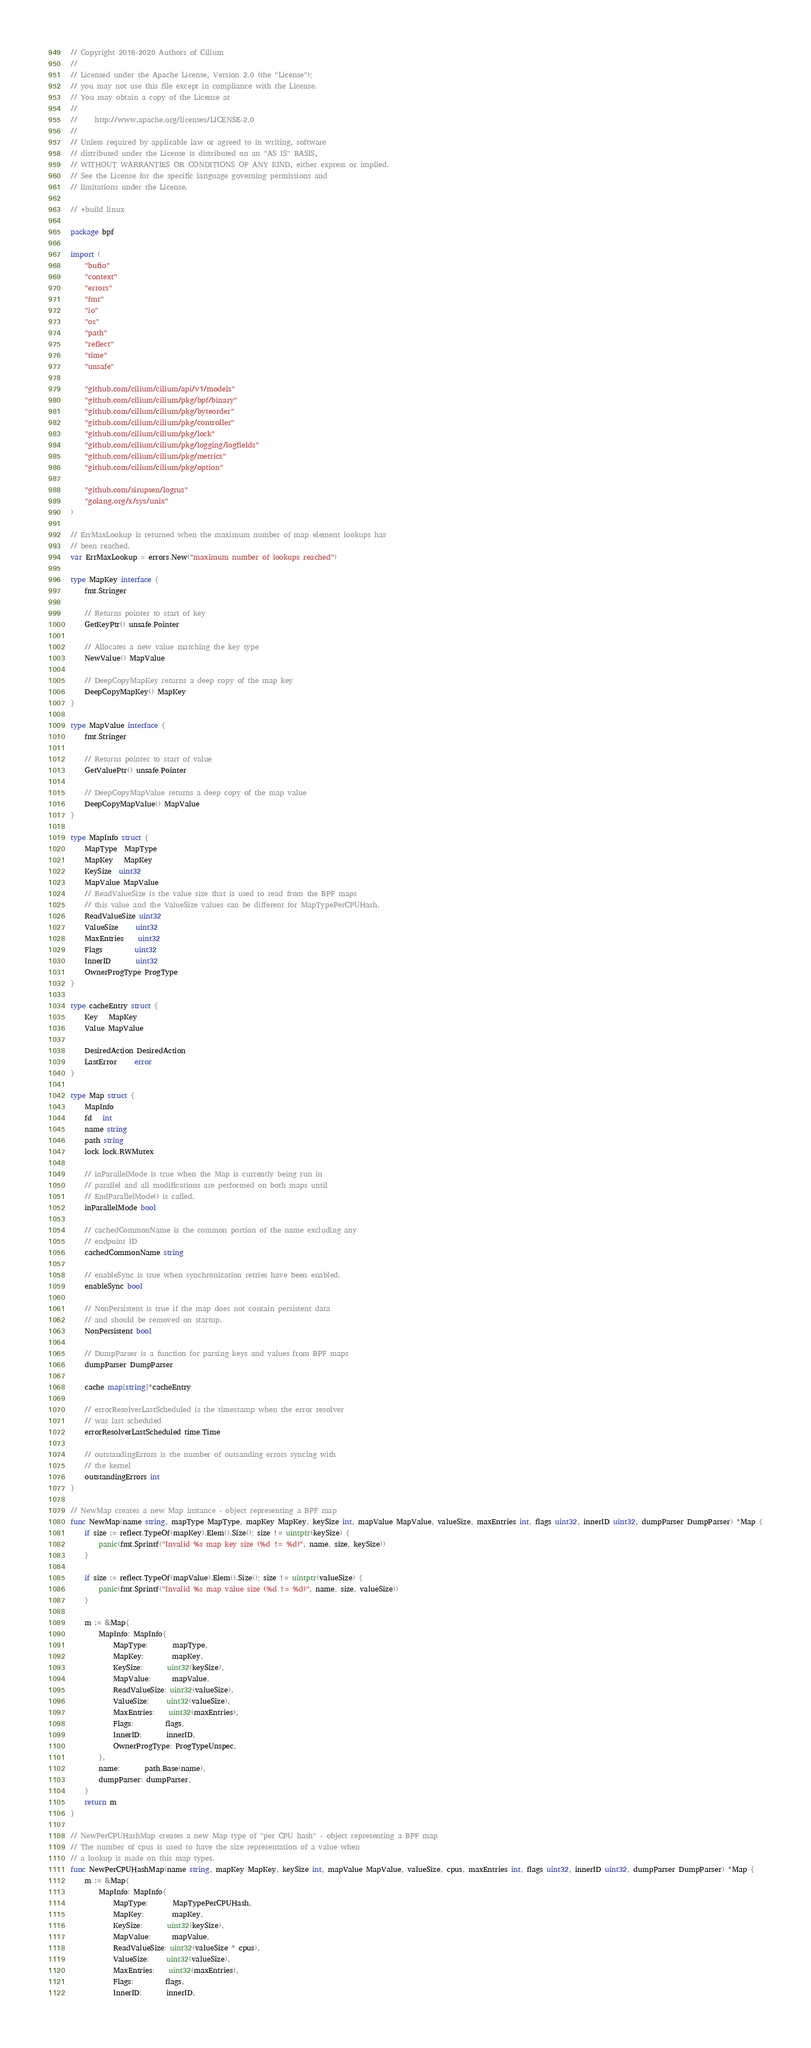<code> <loc_0><loc_0><loc_500><loc_500><_Go_>// Copyright 2016-2020 Authors of Cilium
//
// Licensed under the Apache License, Version 2.0 (the "License");
// you may not use this file except in compliance with the License.
// You may obtain a copy of the License at
//
//     http://www.apache.org/licenses/LICENSE-2.0
//
// Unless required by applicable law or agreed to in writing, software
// distributed under the License is distributed on an "AS IS" BASIS,
// WITHOUT WARRANTIES OR CONDITIONS OF ANY KIND, either express or implied.
// See the License for the specific language governing permissions and
// limitations under the License.

// +build linux

package bpf

import (
	"bufio"
	"context"
	"errors"
	"fmt"
	"io"
	"os"
	"path"
	"reflect"
	"time"
	"unsafe"

	"github.com/cilium/cilium/api/v1/models"
	"github.com/cilium/cilium/pkg/bpf/binary"
	"github.com/cilium/cilium/pkg/byteorder"
	"github.com/cilium/cilium/pkg/controller"
	"github.com/cilium/cilium/pkg/lock"
	"github.com/cilium/cilium/pkg/logging/logfields"
	"github.com/cilium/cilium/pkg/metrics"
	"github.com/cilium/cilium/pkg/option"

	"github.com/sirupsen/logrus"
	"golang.org/x/sys/unix"
)

// ErrMaxLookup is returned when the maximum number of map element lookups has
// been reached.
var ErrMaxLookup = errors.New("maximum number of lookups reached")

type MapKey interface {
	fmt.Stringer

	// Returns pointer to start of key
	GetKeyPtr() unsafe.Pointer

	// Allocates a new value matching the key type
	NewValue() MapValue

	// DeepCopyMapKey returns a deep copy of the map key
	DeepCopyMapKey() MapKey
}

type MapValue interface {
	fmt.Stringer

	// Returns pointer to start of value
	GetValuePtr() unsafe.Pointer

	// DeepCopyMapValue returns a deep copy of the map value
	DeepCopyMapValue() MapValue
}

type MapInfo struct {
	MapType  MapType
	MapKey   MapKey
	KeySize  uint32
	MapValue MapValue
	// ReadValueSize is the value size that is used to read from the BPF maps
	// this value and the ValueSize values can be different for MapTypePerCPUHash.
	ReadValueSize uint32
	ValueSize     uint32
	MaxEntries    uint32
	Flags         uint32
	InnerID       uint32
	OwnerProgType ProgType
}

type cacheEntry struct {
	Key   MapKey
	Value MapValue

	DesiredAction DesiredAction
	LastError     error
}

type Map struct {
	MapInfo
	fd   int
	name string
	path string
	lock lock.RWMutex

	// inParallelMode is true when the Map is currently being run in
	// parallel and all modifications are performed on both maps until
	// EndParallelMode() is called.
	inParallelMode bool

	// cachedCommonName is the common portion of the name excluding any
	// endpoint ID
	cachedCommonName string

	// enableSync is true when synchronization retries have been enabled.
	enableSync bool

	// NonPersistent is true if the map does not contain persistent data
	// and should be removed on startup.
	NonPersistent bool

	// DumpParser is a function for parsing keys and values from BPF maps
	dumpParser DumpParser

	cache map[string]*cacheEntry

	// errorResolverLastScheduled is the timestamp when the error resolver
	// was last scheduled
	errorResolverLastScheduled time.Time

	// outstandingErrors is the number of outsanding errors syncing with
	// the kernel
	outstandingErrors int
}

// NewMap creates a new Map instance - object representing a BPF map
func NewMap(name string, mapType MapType, mapKey MapKey, keySize int, mapValue MapValue, valueSize, maxEntries int, flags uint32, innerID uint32, dumpParser DumpParser) *Map {
	if size := reflect.TypeOf(mapKey).Elem().Size(); size != uintptr(keySize) {
		panic(fmt.Sprintf("Invalid %s map key size (%d != %d)", name, size, keySize))
	}

	if size := reflect.TypeOf(mapValue).Elem().Size(); size != uintptr(valueSize) {
		panic(fmt.Sprintf("Invalid %s map value size (%d != %d)", name, size, valueSize))
	}

	m := &Map{
		MapInfo: MapInfo{
			MapType:       mapType,
			MapKey:        mapKey,
			KeySize:       uint32(keySize),
			MapValue:      mapValue,
			ReadValueSize: uint32(valueSize),
			ValueSize:     uint32(valueSize),
			MaxEntries:    uint32(maxEntries),
			Flags:         flags,
			InnerID:       innerID,
			OwnerProgType: ProgTypeUnspec,
		},
		name:       path.Base(name),
		dumpParser: dumpParser,
	}
	return m
}

// NewPerCPUHashMap creates a new Map type of "per CPU hash" - object representing a BPF map
// The number of cpus is used to have the size representation of a value when
// a lookup is made on this map types.
func NewPerCPUHashMap(name string, mapKey MapKey, keySize int, mapValue MapValue, valueSize, cpus, maxEntries int, flags uint32, innerID uint32, dumpParser DumpParser) *Map {
	m := &Map{
		MapInfo: MapInfo{
			MapType:       MapTypePerCPUHash,
			MapKey:        mapKey,
			KeySize:       uint32(keySize),
			MapValue:      mapValue,
			ReadValueSize: uint32(valueSize * cpus),
			ValueSize:     uint32(valueSize),
			MaxEntries:    uint32(maxEntries),
			Flags:         flags,
			InnerID:       innerID,</code> 